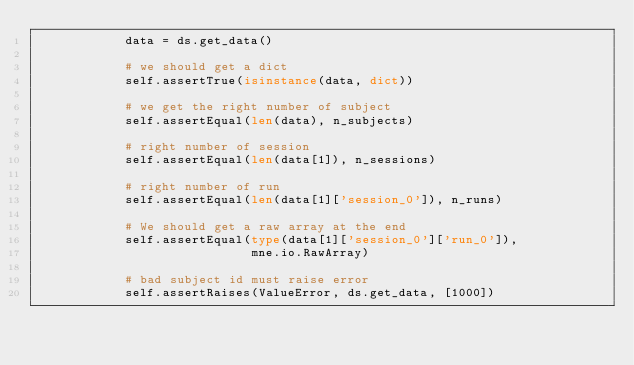<code> <loc_0><loc_0><loc_500><loc_500><_Python_>            data = ds.get_data()

            # we should get a dict
            self.assertTrue(isinstance(data, dict))

            # we get the right number of subject
            self.assertEqual(len(data), n_subjects)

            # right number of session
            self.assertEqual(len(data[1]), n_sessions)

            # right number of run
            self.assertEqual(len(data[1]['session_0']), n_runs)

            # We should get a raw array at the end
            self.assertEqual(type(data[1]['session_0']['run_0']),
                             mne.io.RawArray)

            # bad subject id must raise error
            self.assertRaises(ValueError, ds.get_data, [1000])
</code> 